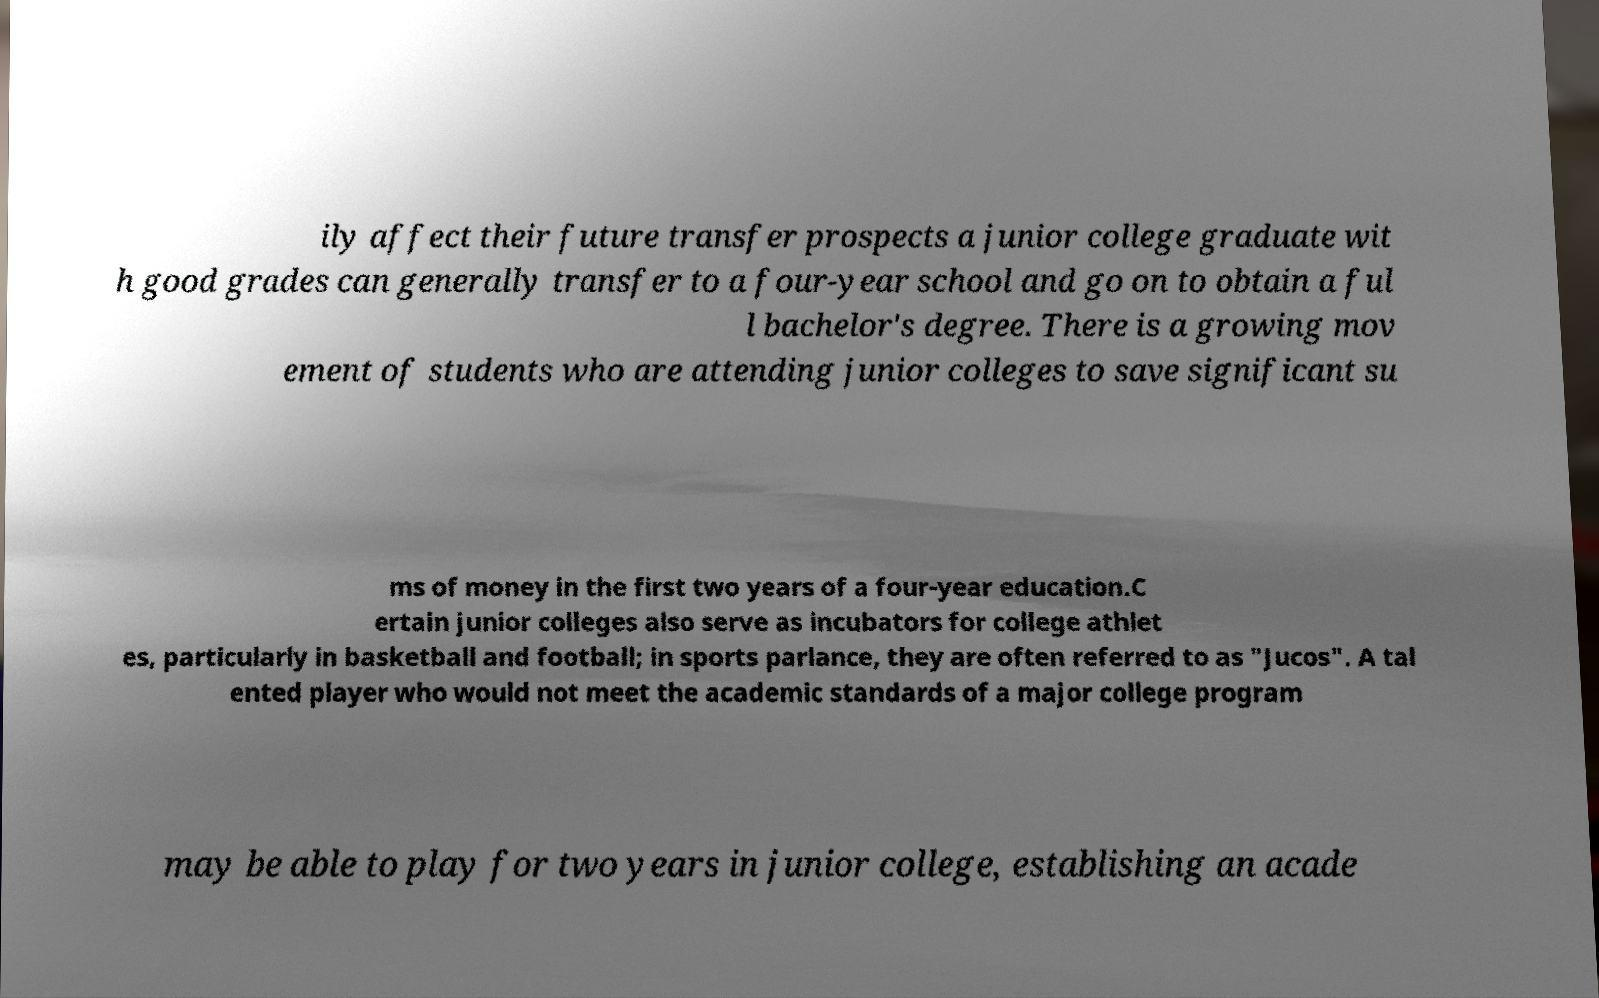I need the written content from this picture converted into text. Can you do that? ily affect their future transfer prospects a junior college graduate wit h good grades can generally transfer to a four-year school and go on to obtain a ful l bachelor's degree. There is a growing mov ement of students who are attending junior colleges to save significant su ms of money in the first two years of a four-year education.C ertain junior colleges also serve as incubators for college athlet es, particularly in basketball and football; in sports parlance, they are often referred to as "Jucos". A tal ented player who would not meet the academic standards of a major college program may be able to play for two years in junior college, establishing an acade 